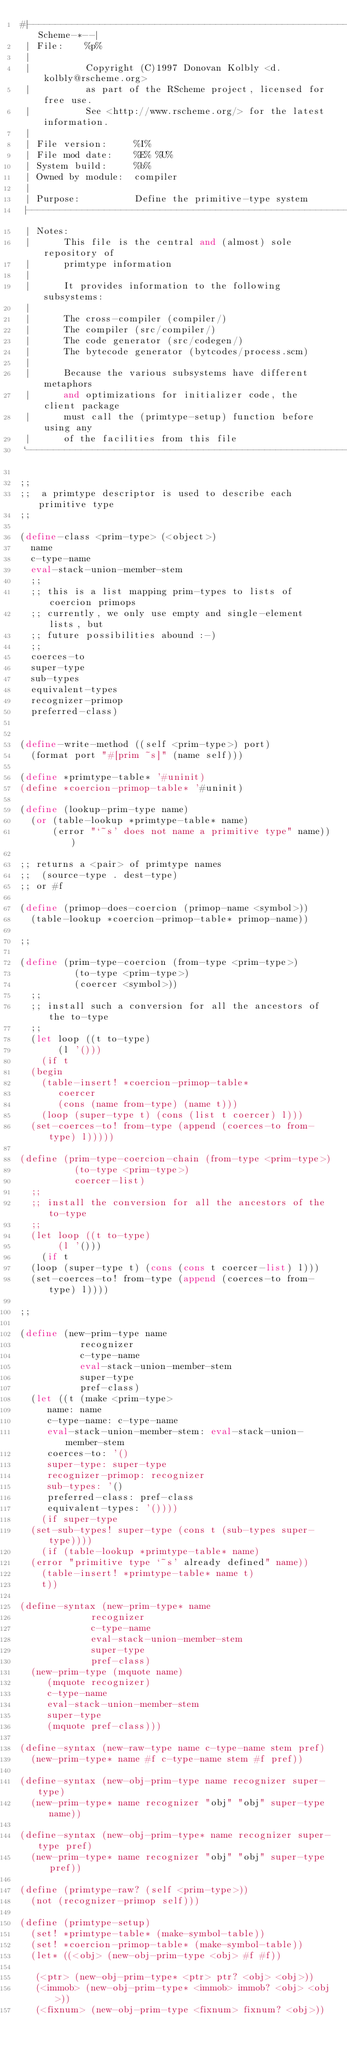Convert code to text. <code><loc_0><loc_0><loc_500><loc_500><_Scheme_>#|------------------------------------------------------------*-Scheme-*--|
 | File:    %p%
 |
 |          Copyright (C)1997 Donovan Kolbly <d.kolbly@rscheme.org>
 |          as part of the RScheme project, licensed for free use.
 |          See <http://www.rscheme.org/> for the latest information.
 |
 | File version:     %I%
 | File mod date:    %E% %U%
 | System build:     %b%
 | Owned by module:  compiler
 |
 | Purpose:          Define the primitive-type system
 |------------------------------------------------------------------------|
 | Notes:
 |      This file is the central and (almost) sole repository of
 |      primtype information
 |      
 |      It provides information to the following subsystems:
 |      
 |      The cross-compiler (compiler/)
 |      The compiler (src/compiler/)
 |      The code generator (src/codegen/)
 |      The bytecode generator (bytcodes/process.scm)
 |      
 |      Because the various subsystems have different metaphors
 |      and optimizations for initializer code, the client package
 |      must call the (primtype-setup) function before using any
 |      of the facilities from this file
 `------------------------------------------------------------------------|#

;;
;;  a primtype descriptor is used to describe each primitive type
;;

(define-class <prim-type> (<object>)
  name
  c-type-name
  eval-stack-union-member-stem
  ;;
  ;; this is a list mapping prim-types to lists of coercion primops
  ;; currently, we only use empty and single-element lists, but
  ;; future possibilities abound :-)
  ;;
  coerces-to
  super-type
  sub-types
  equivalent-types
  recognizer-primop
  preferred-class)


(define-write-method ((self <prim-type>) port)
  (format port "#[prim ~s]" (name self)))

(define *primtype-table* '#uninit)
(define *coercion-primop-table* '#uninit)

(define (lookup-prim-type name)
  (or (table-lookup *primtype-table* name)
      (error "`~s' does not name a primitive type" name)))

;; returns a <pair> of primtype names
;;  (source-type . dest-type)
;; or #f

(define (primop-does-coercion (primop-name <symbol>))
  (table-lookup *coercion-primop-table* primop-name))

;;

(define (prim-type-coercion (from-type <prim-type>)
			    (to-type <prim-type>)
			    (coercer <symbol>))
  ;;
  ;; install such a conversion for all the ancestors of the to-type
  ;;
  (let loop ((t to-type)
	     (l '()))
    (if t
	(begin
	  (table-insert! *coercion-primop-table*
			 coercer
			 (cons (name from-type) (name t)))
	  (loop (super-type t) (cons (list t coercer) l)))
	(set-coerces-to! from-type (append (coerces-to from-type) l)))))

(define (prim-type-coercion-chain (from-type <prim-type>)
				  (to-type <prim-type>)
				  coercer-list)
  ;;
  ;; install the conversion for all the ancestors of the to-type
  ;;
  (let loop ((t to-type)
	     (l '()))
    (if t
	(loop (super-type t) (cons (cons t coercer-list) l)))
	(set-coerces-to! from-type (append (coerces-to from-type) l))))

;;

(define (new-prim-type name
		       recognizer
		       c-type-name
		       eval-stack-union-member-stem
		       super-type
		       pref-class)
  (let ((t (make <prim-type>
		 name: name
		 c-type-name: c-type-name
		 eval-stack-union-member-stem: eval-stack-union-member-stem
		 coerces-to: '()
		 super-type: super-type
		 recognizer-primop: recognizer
		 sub-types: '()
		 preferred-class: pref-class
		 equivalent-types: '())))
    (if super-type
	(set-sub-types! super-type (cons t (sub-types super-type))))
    (if (table-lookup *primtype-table* name)
	(error "primitive type `~s' already defined" name))
    (table-insert! *primtype-table* name t)
    t))

(define-syntax (new-prim-type* name
			       recognizer
			       c-type-name
			       eval-stack-union-member-stem
			       super-type
			       pref-class)
  (new-prim-type (mquote name)
		 (mquote recognizer) 
		 c-type-name
		 eval-stack-union-member-stem
		 super-type
		 (mquote pref-class)))

(define-syntax (new-raw-type name c-type-name stem pref)
  (new-prim-type* name #f c-type-name stem #f pref))

(define-syntax (new-obj-prim-type name recognizer super-type)
  (new-prim-type* name recognizer "obj" "obj" super-type name))

(define-syntax (new-obj-prim-type* name recognizer super-type pref)
  (new-prim-type* name recognizer "obj" "obj" super-type pref))

(define (primtype-raw? (self <prim-type>))
  (not (recognizer-primop self)))

(define (primtype-setup)
  (set! *primtype-table* (make-symbol-table))
  (set! *coercion-primop-table* (make-symbol-table))
  (let* ((<obj> (new-obj-prim-type <obj> #f #f))

	 (<ptr> (new-obj-prim-type* <ptr> ptr? <obj> <obj>))
	 (<immob> (new-obj-prim-type* <immob> immob? <obj> <obj>))
	 (<fixnum> (new-obj-prim-type <fixnum> fixnum? <obj>))
</code> 